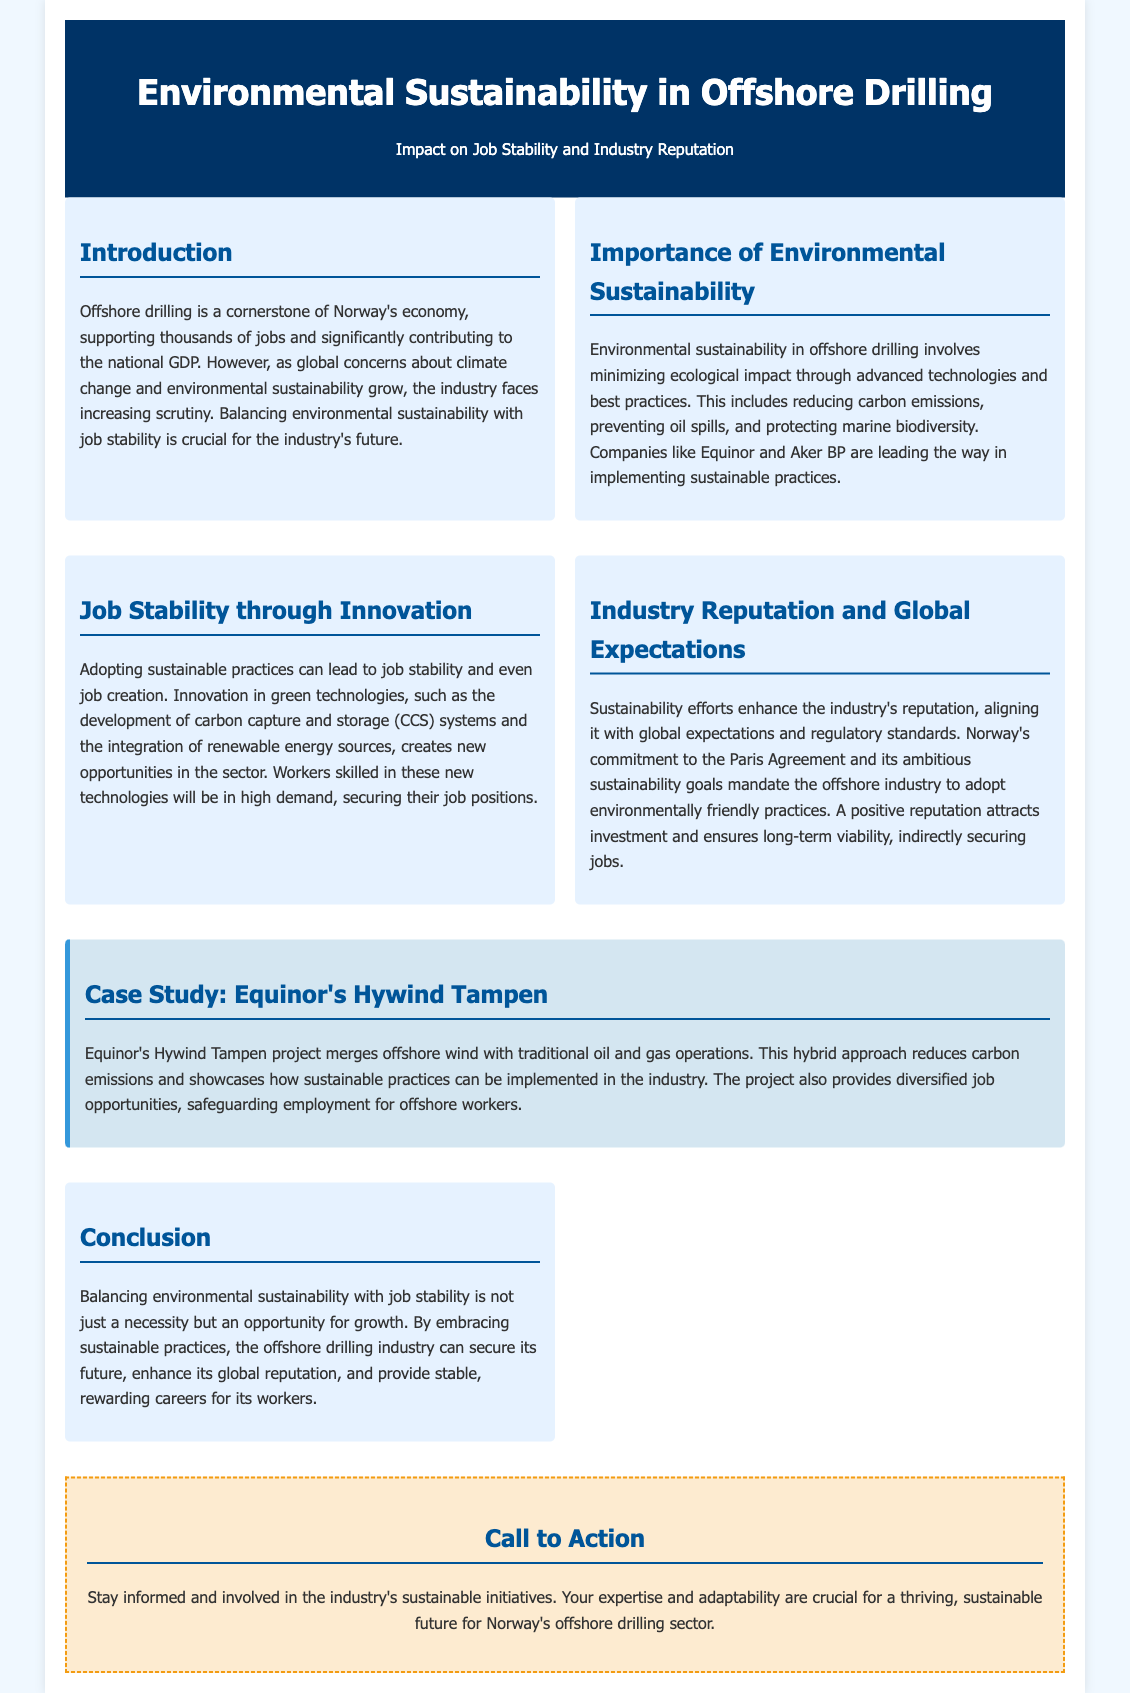what is the main focus of the flyer? The flyer focuses on environmental sustainability in offshore drilling and its impact on job stability and industry reputation.
Answer: environmental sustainability in offshore drilling who are the leading companies mentioned in sustainable practices? The companies mentioned are Equinor and Aker BP, known for implementing sustainable practices.
Answer: Equinor and Aker BP what project is cited as a case study in the document? The case study discussed is Equinor's Hywind Tampen project.
Answer: Hywind Tampen how does adopting sustainable practices affect job opportunities? Adopting sustainable practices can lead to job stability and even job creation due to innovation in green technologies.
Answer: job stability and creation what effect does sustainability have on the industry’s reputation? Sustainability efforts enhance the industry's reputation, aligning it with global expectations and regulatory standards.
Answer: enhances the industry’s reputation what technology is specifically mentioned as part of innovation in the industry? The technology mentioned is carbon capture and storage (CCS) systems.
Answer: carbon capture and storage systems what kind of careers is the industry aiming to provide according to the conclusion? The industry aims to provide stable, rewarding careers for its workers.
Answer: stable, rewarding careers what is the call to action for workers in the offshore drilling sector? The call to action encourages workers to stay informed and involved in the industry’s sustainable initiatives.
Answer: stay informed and involved 